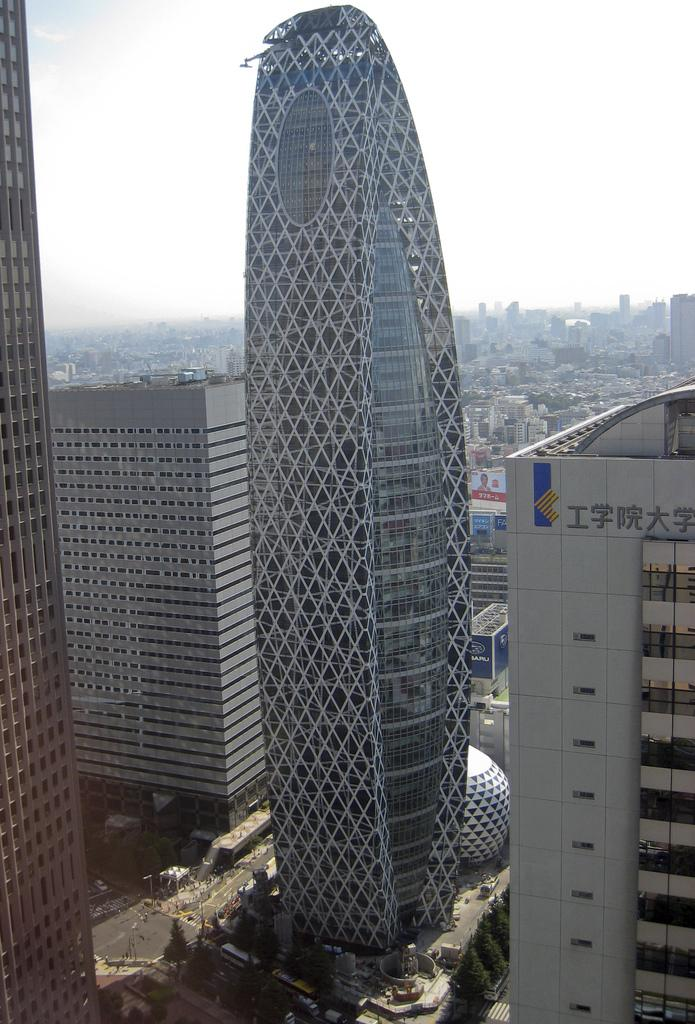What type of structures can be seen in the middle of the picture? There are buildings in the middle of the picture. What can be seen at the bottom of the picture? There are roads visible at the bottom of the picture. What is visible in the background of the image? The sky is visible in the background of the image. How many pizzas are being delivered on the roads in the image? There are no pizzas or deliveries visible in the image; it only shows buildings, roads, and the sky. 